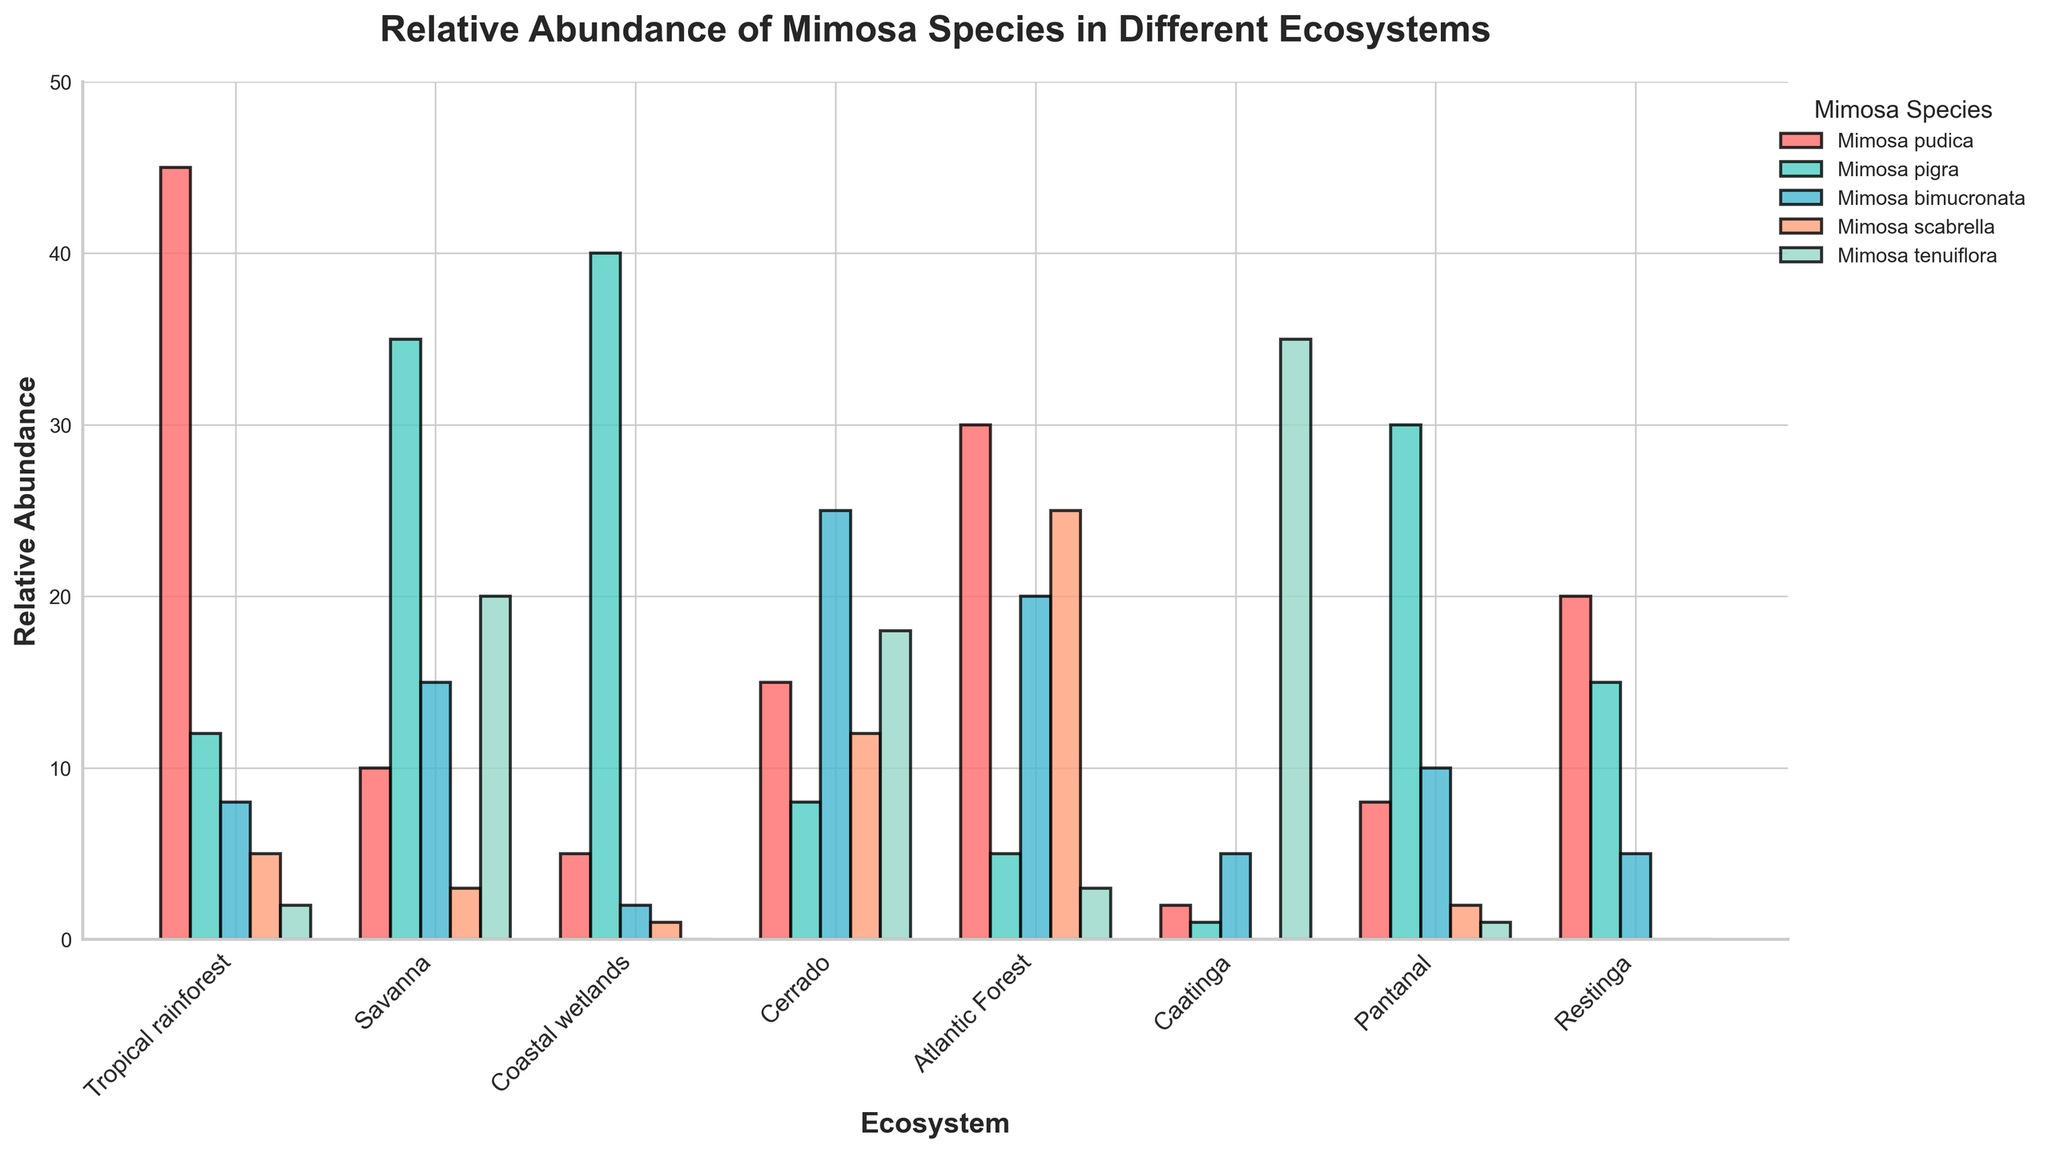Which ecosystem has the highest relative abundance of Mimosa pudica? Mimosa pudica has the highest bar (red) in the Tropical rainforest ecosystem.
Answer: Tropical rainforest Compare the abundance of Mimosa pigra in the Savanna and Pantanal ecosystems. In the Savanna, the bar (light green) representing Mimosa pigra is taller compared to that in the Pantanal. Specifically, Mimosa pigra is 35 in the Savanna and 30 in the Pantanal.
Answer: Savanna Which species shows the highest relative abundance in the Caatinga ecosystem? The highest bar in the Caatinga ecosystem is a blue bar, representing Mimosa tenuiflora.
Answer: Mimosa tenuiflora What is the combined relative abundance of Mimosa bimucronata and Mimosa scabrella in the Atlantic Forest ecosystem? The values for Mimosa bimucronata and Mimosa scabrella in the Atlantic Forest ecosystem are 20 and 25 respectively. Adding them gives 20 + 25.
Answer: 45 Is the relative abundance of Mimosa pudica greater in the Tropical rainforest or in the Atlantic Forest? The bar (red) for Mimosa pudica is higher in the Tropical rainforest (45) than in the Atlantic Forest (30).
Answer: Tropical rainforest Which Mimosa species has the lowest abundance in the Coastal wetlands? The lowest bars in the Coastal wetlands correspond to Mimosa bimucronata (2) and Mimosa scabrella (1). However, there is no bar for Mimosa tenuiflora, indicating its abundance is 0.
Answer: Mimosa tenuiflora Across all ecosystems, which color bar is the tallest and what species does it represent? Reviewing the figure, the tallest bar is the light green bar representing Mimosa pigra in the Coastal wetlands.
Answer: Mimosa pigra Are there any ecosystems where the abundance of Mimosa scabrella is zero? Review each ecosystem's section for the absence of the orange bar. Mimosa scabrella is absent (bar height is zero) in Restinga and Caatinga.
Answer: Restinga and Caatinga What is the difference in relative abundance of Mimosa pigra between the Savanna and Cerrado ecosystems? Mimosa pigra in the Savanna is 35, and in Cerrado is 8. The difference is 35 - 8.
Answer: 27 